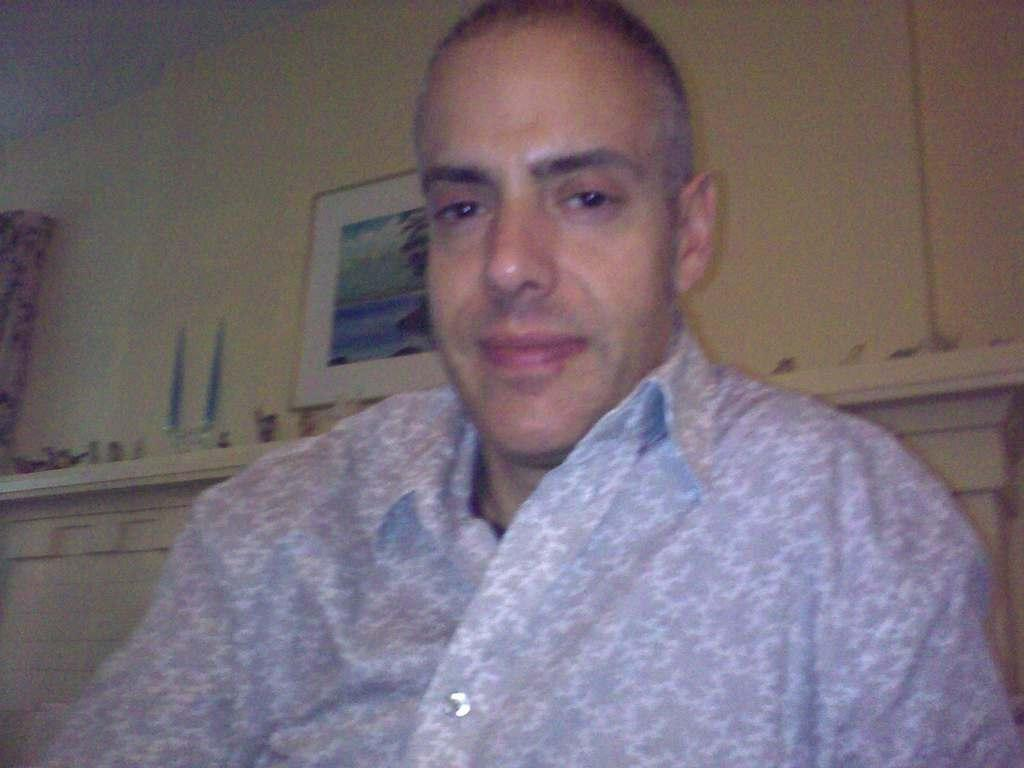What is the man in the image doing? The man is sitting in the image. What is the man wearing? The man is wearing a shirt. What is the man's facial expression? The man is smiling. What can be seen in the background of the image? There is a wall in the background of the image. What is on the wall in the image? There is a photo frame on the wall. What caption is written on the photo frame in the image? There is no caption visible on the photo frame in the image. What type of crime is being committed in the image? There is no crime being committed in the image; it features a man sitting and smiling. 